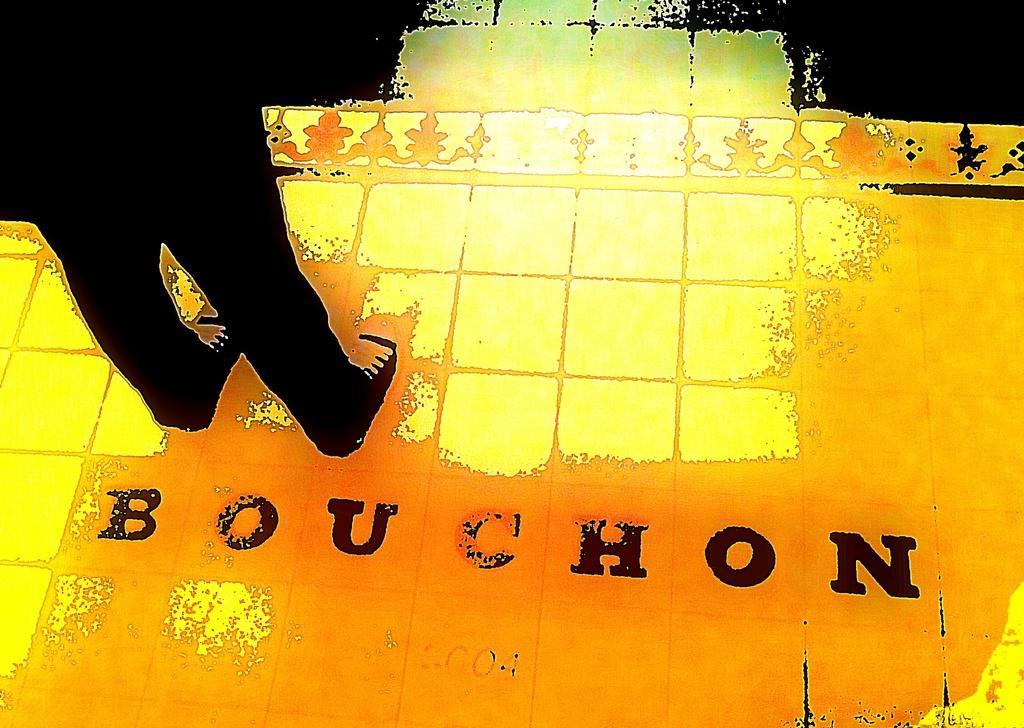How would you summarize this image in a sentence or two? This image is an edited image. On the left side of the image we can see a person's legs. At the bottom there is a floor and we can see text. 